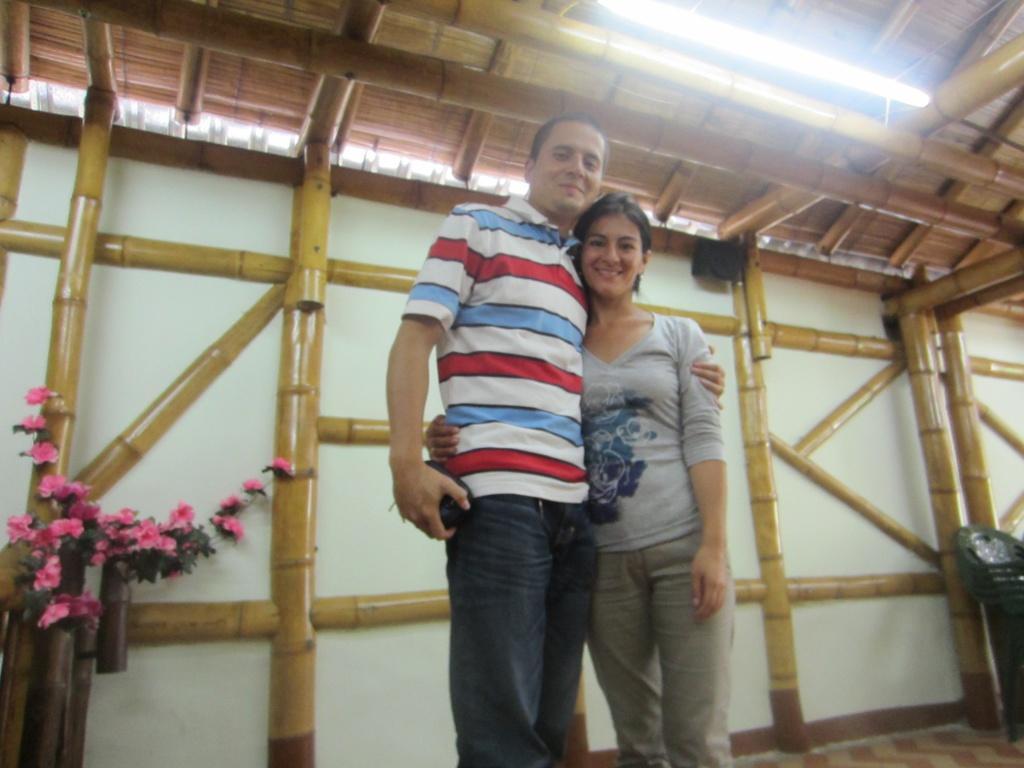Could you give a brief overview of what you see in this image? In this picture we can see a man and a woman standing and smiling on the path. There are few pink flowers on the left side. We can see a tube light on top. There is a dustbin on the right side. This is an wooden building. 